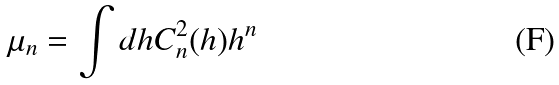<formula> <loc_0><loc_0><loc_500><loc_500>\mu _ { n } = \int d h C _ { n } ^ { 2 } ( h ) h ^ { n }</formula> 